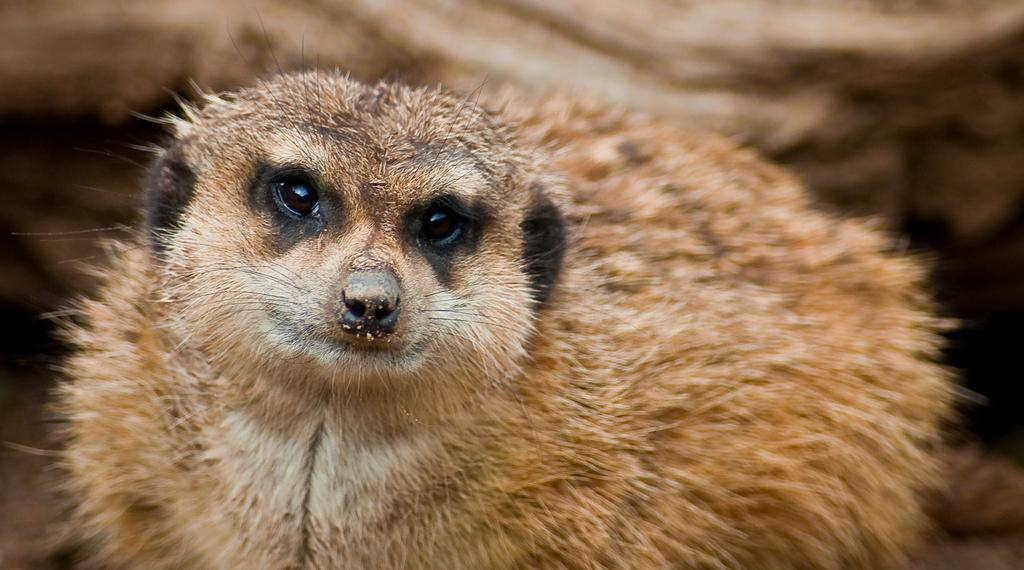What type of creature is present in the image? There is an animal in the image. Can you describe the coloring of the animal? The animal has brown and white coloring. What type of hook can be seen attached to the animal in the image? There is no hook present in the image; it only features an animal with brown and white coloring. 